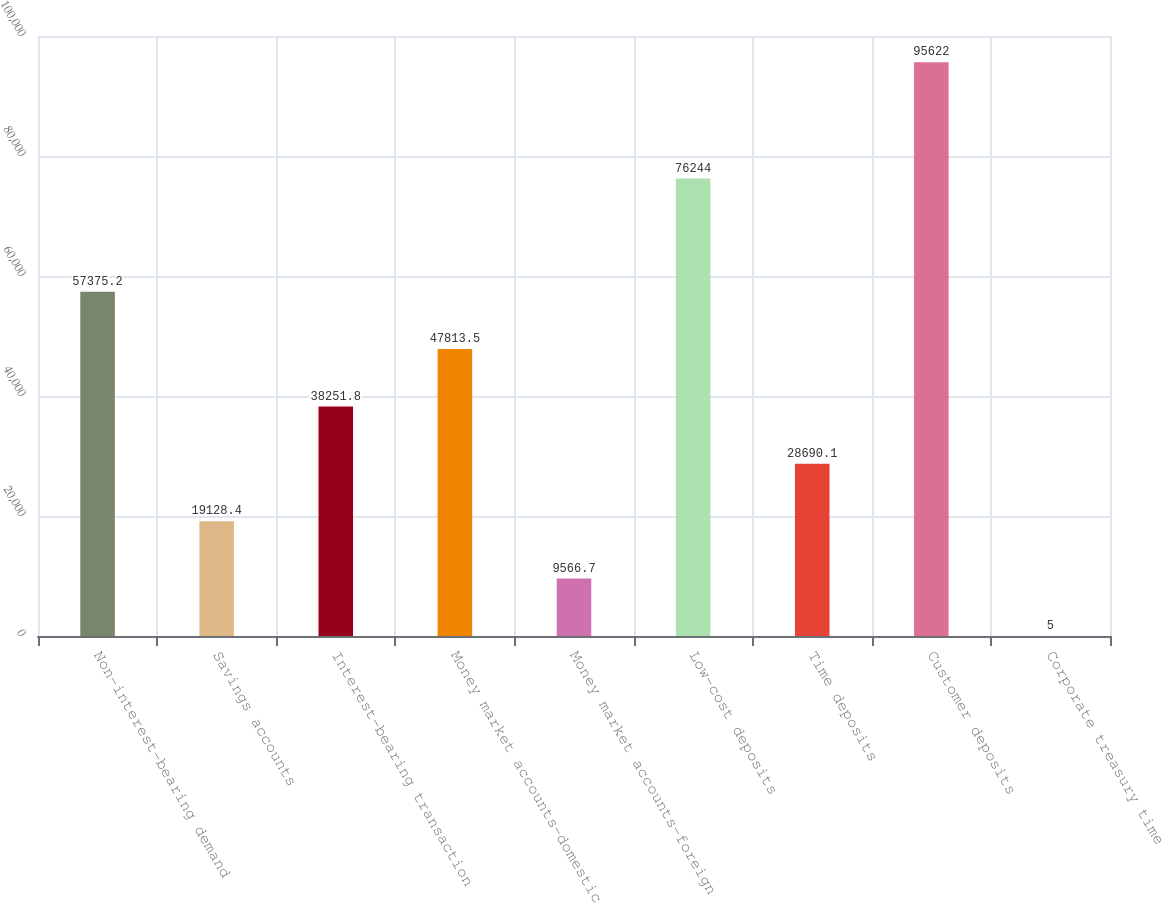<chart> <loc_0><loc_0><loc_500><loc_500><bar_chart><fcel>Non-interest-bearing demand<fcel>Savings accounts<fcel>Interest-bearing transaction<fcel>Money market accounts-domestic<fcel>Money market accounts-foreign<fcel>Low-cost deposits<fcel>Time deposits<fcel>Customer deposits<fcel>Corporate treasury time<nl><fcel>57375.2<fcel>19128.4<fcel>38251.8<fcel>47813.5<fcel>9566.7<fcel>76244<fcel>28690.1<fcel>95622<fcel>5<nl></chart> 